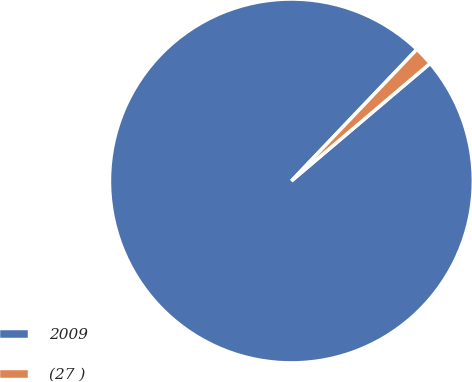<chart> <loc_0><loc_0><loc_500><loc_500><pie_chart><fcel>2009<fcel>(27 )<nl><fcel>98.31%<fcel>1.69%<nl></chart> 